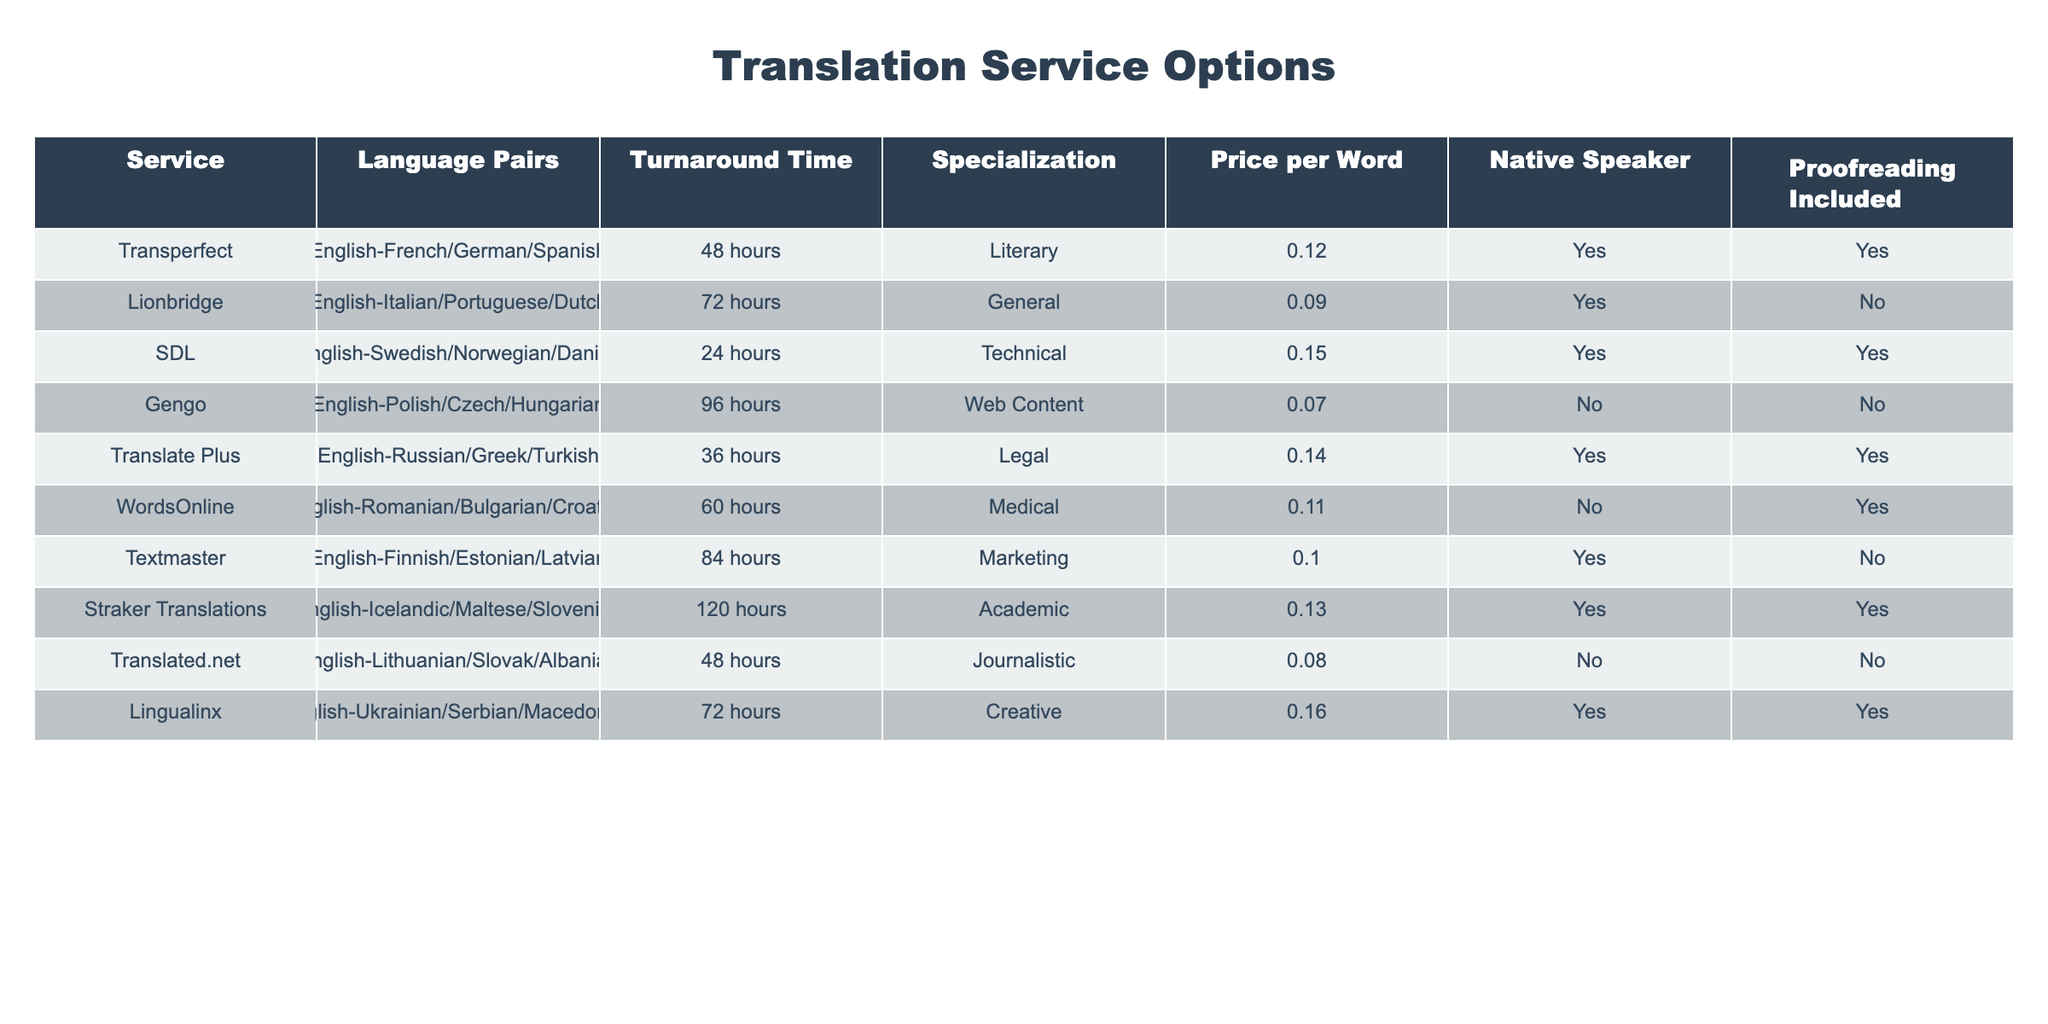What are the service options for translating English to French? The table indicates that Transperfect offers English to French translation with a specialization in Literary work, a turnaround time of 48 hours, a price of 0.12 per word, includes native speakers, and includes proofreading.
Answer: Transperfect Which service has the longest turnaround time? By examining the table, Straker Translations has the longest turnaround time of 120 hours for the language pairs English-Icelandic/Maltese/Slovenian.
Answer: 120 hours Which service offers the lowest price per word for English to Polish translations? Gengo provides English to Polish translations at the lowest price of 0.07 per word, while other services either charge more or do not offer this language pair.
Answer: 0.07 Is proofreading included in the translation service from Lionbridge? According to the table, Lionbridge does not include proofreading for their English to Italian/Portuguese/Dutch translations, as indicated in the Proofreading Included column.
Answer: No If I need to translate English to a Scandinavian language, which service should I choose for the quickest turnaround time? The table shows SDL offers the quickest turnaround time of 24 hours for translating English to Swedish/Norwegian/Danish, making it the best choice for urgent Scandinavian translations.
Answer: SDL How many services include native speakers for translations into the given language pairs? By counting the rows where the Native Speaker column indicates "Yes," we find that 6 services (Transperfect, SDL, Translate Plus, WordsOnline, Textmaster, and Lingualinx) provide native speakers for their translation services.
Answer: 6 Which translation service provides both the quickest turnaround time and includes proofreading? The table highlights that SDL offers a 24-hour turnaround time alongside proofreading for English to Swedish/Norwegian/Danish translations, making it the only service that meets both criteria.
Answer: SDL What is the average price per word for services that include proofreading? The services that include proofreading are Transperfect (0.12), SDL (0.15), Translate Plus (0.14), WordsOnline (0.11), and Straker Translations (0.13). The average price is calculated as follows: (0.12 + 0.15 + 0.14 + 0.11 + 0.13) / 5 = 0.13.
Answer: 0.13 